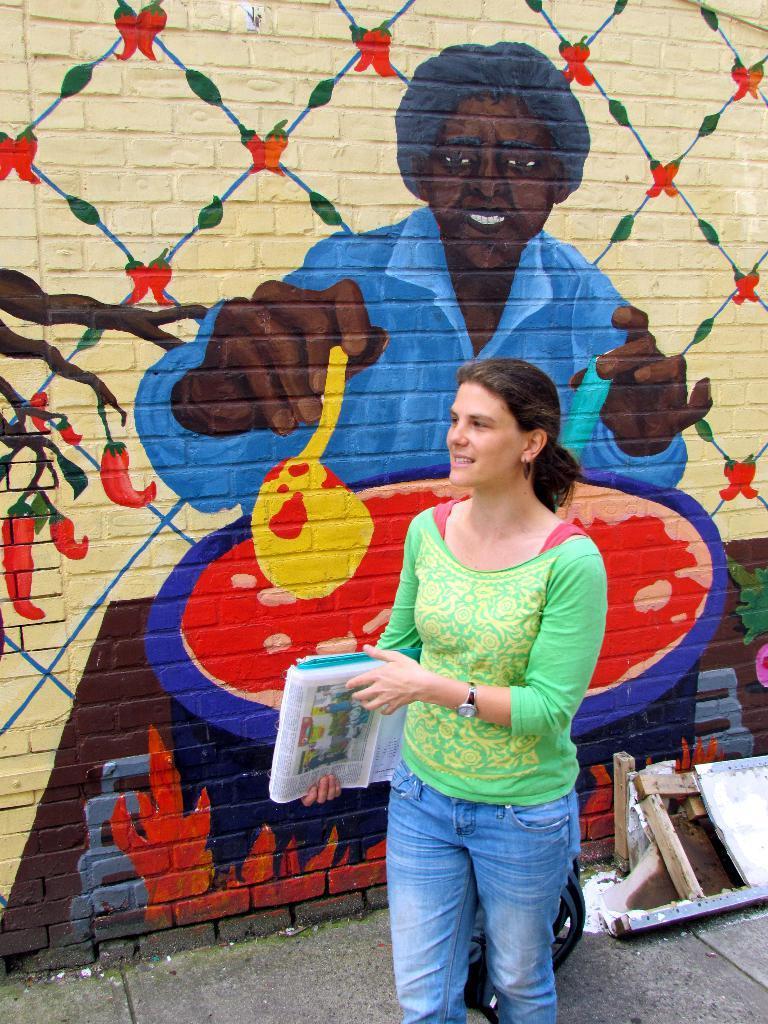Describe this image in one or two sentences. In this image we can see a woman is standing on the ground, and smiling, and holding papers in the hand, there is a wall painting, and there are some objects on the ground. 